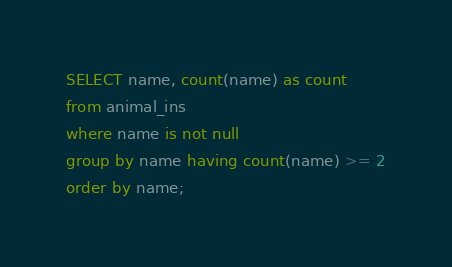<code> <loc_0><loc_0><loc_500><loc_500><_SQL_>SELECT name, count(name) as count
from animal_ins
where name is not null
group by name having count(name) >= 2
order by name;</code> 